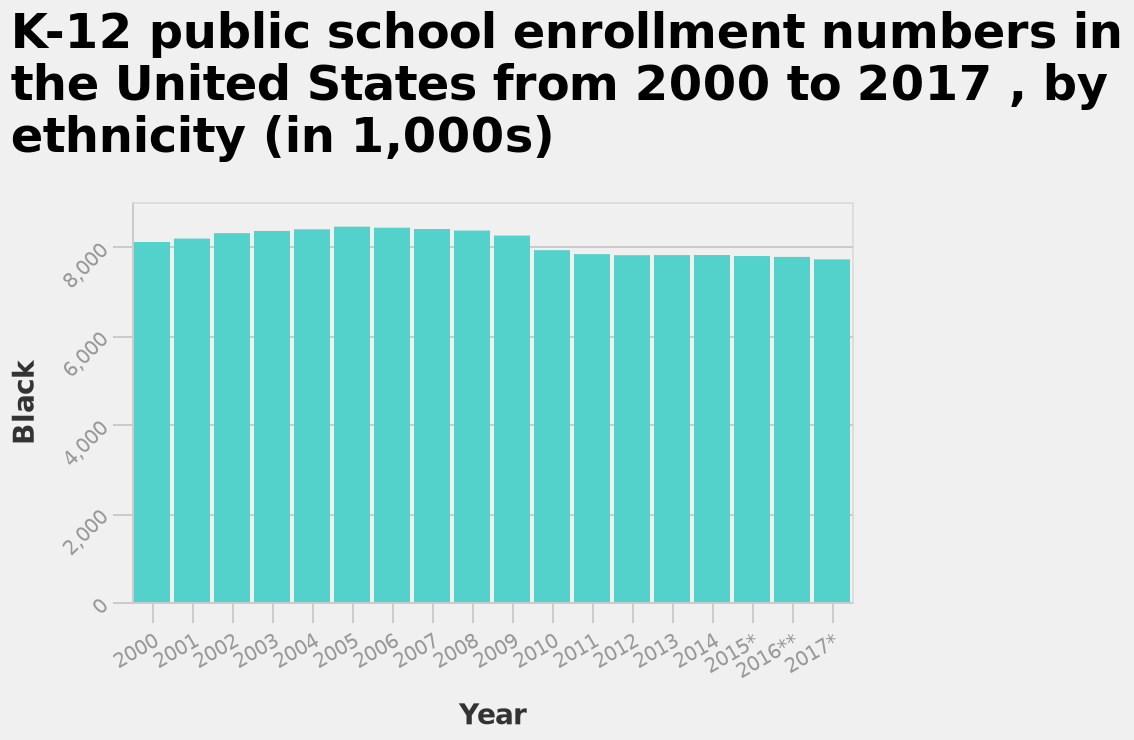<image>
 What does the bar plot show about ethnicity?  The bar plot shows the enrollment numbers by ethnicity, specifically focusing on the Black population in K-12 public schools. How would you describe the trend in enrolment numbers of Black students? The trend in enrolment numbers of Black students is a steady decline since 2005.  What does the y-axis measure in the bar plot?  The y-axis measures the enrollment numbers of Black students in thousands. please enumerates aspects of the construction of the chart This bar plot is named K-12 public school enrollment numbers in the United States from 2000 to 2017 , by ethnicity (in 1,000s). The x-axis shows Year while the y-axis measures Black. 